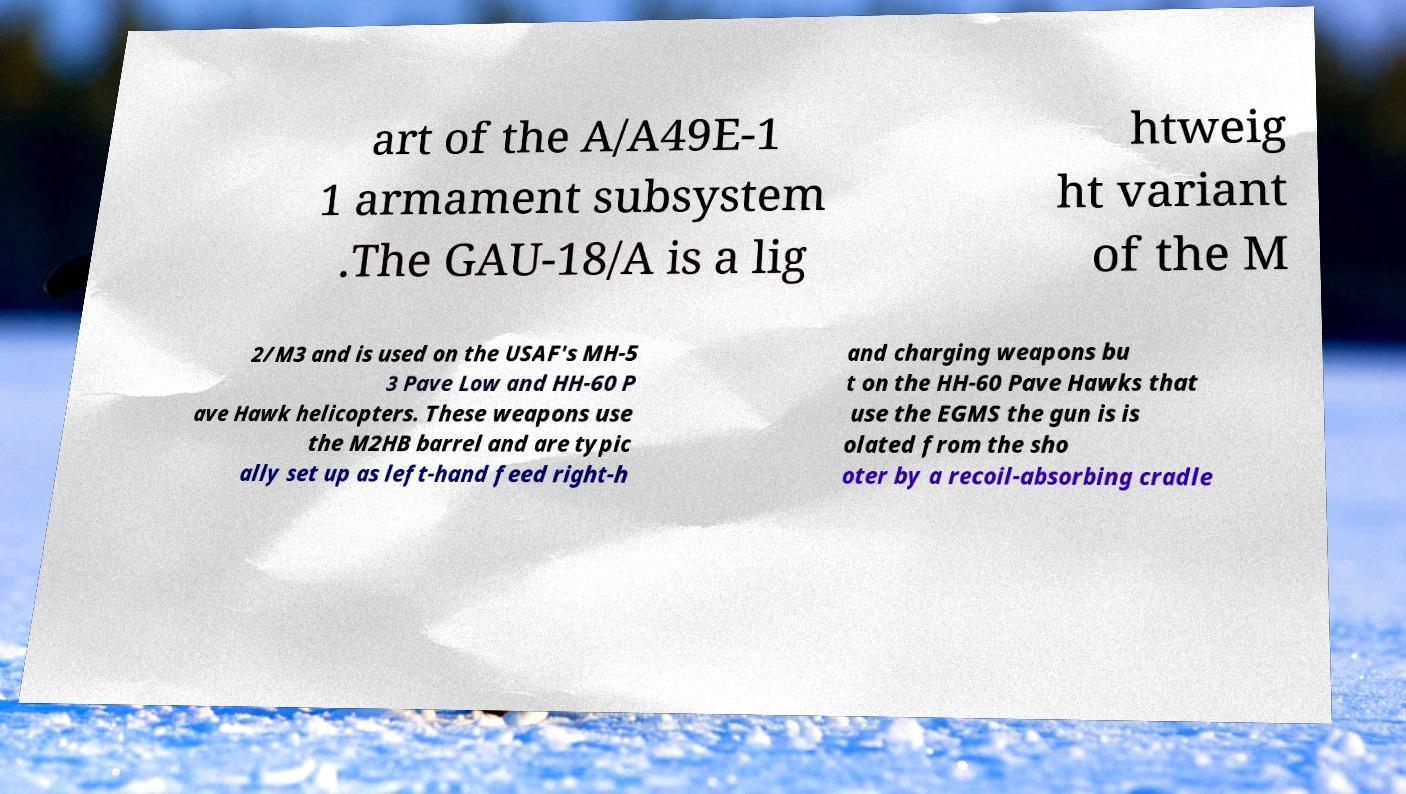Could you assist in decoding the text presented in this image and type it out clearly? art of the A/A49E-1 1 armament subsystem .The GAU-18/A is a lig htweig ht variant of the M 2/M3 and is used on the USAF's MH-5 3 Pave Low and HH-60 P ave Hawk helicopters. These weapons use the M2HB barrel and are typic ally set up as left-hand feed right-h and charging weapons bu t on the HH-60 Pave Hawks that use the EGMS the gun is is olated from the sho oter by a recoil-absorbing cradle 